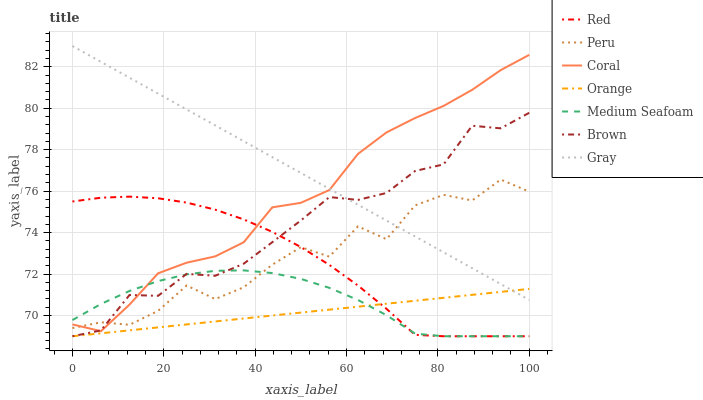Does Coral have the minimum area under the curve?
Answer yes or no. No. Does Coral have the maximum area under the curve?
Answer yes or no. No. Is Coral the smoothest?
Answer yes or no. No. Is Coral the roughest?
Answer yes or no. No. Does Coral have the lowest value?
Answer yes or no. No. Does Coral have the highest value?
Answer yes or no. No. Is Medium Seafoam less than Gray?
Answer yes or no. Yes. Is Coral greater than Orange?
Answer yes or no. Yes. Does Medium Seafoam intersect Gray?
Answer yes or no. No. 